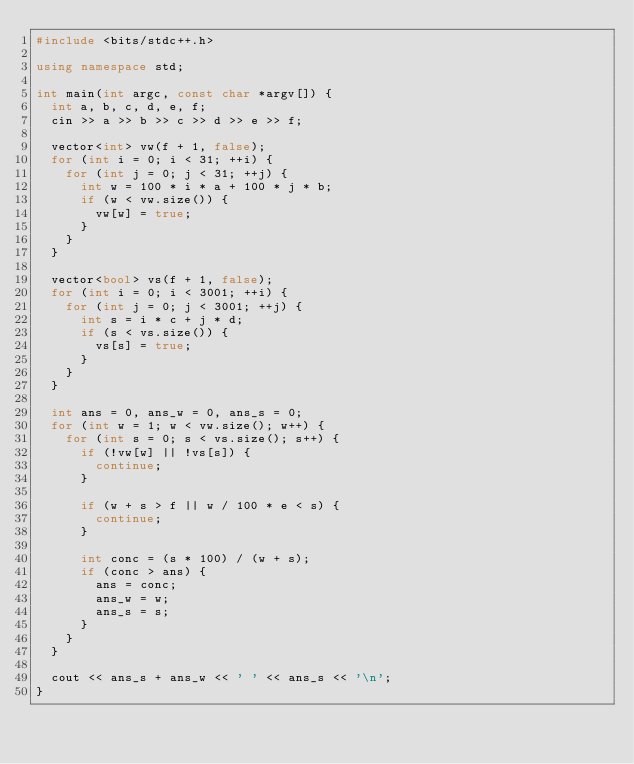<code> <loc_0><loc_0><loc_500><loc_500><_C++_>#include <bits/stdc++.h>

using namespace std;

int main(int argc, const char *argv[]) {
  int a, b, c, d, e, f;
  cin >> a >> b >> c >> d >> e >> f;

  vector<int> vw(f + 1, false);
  for (int i = 0; i < 31; ++i) {
    for (int j = 0; j < 31; ++j) {
      int w = 100 * i * a + 100 * j * b;
      if (w < vw.size()) {
        vw[w] = true;
      }
    }
  }

  vector<bool> vs(f + 1, false);
  for (int i = 0; i < 3001; ++i) {
    for (int j = 0; j < 3001; ++j) {
      int s = i * c + j * d;
      if (s < vs.size()) {
        vs[s] = true;
      }
    }
  }

  int ans = 0, ans_w = 0, ans_s = 0;
  for (int w = 1; w < vw.size(); w++) {
    for (int s = 0; s < vs.size(); s++) {
      if (!vw[w] || !vs[s]) {
        continue;
      }

      if (w + s > f || w / 100 * e < s) {
        continue;
      }

      int conc = (s * 100) / (w + s);
      if (conc > ans) {
        ans = conc;
        ans_w = w;
        ans_s = s;
      }
    }
  }

  cout << ans_s + ans_w << ' ' << ans_s << '\n';
}</code> 